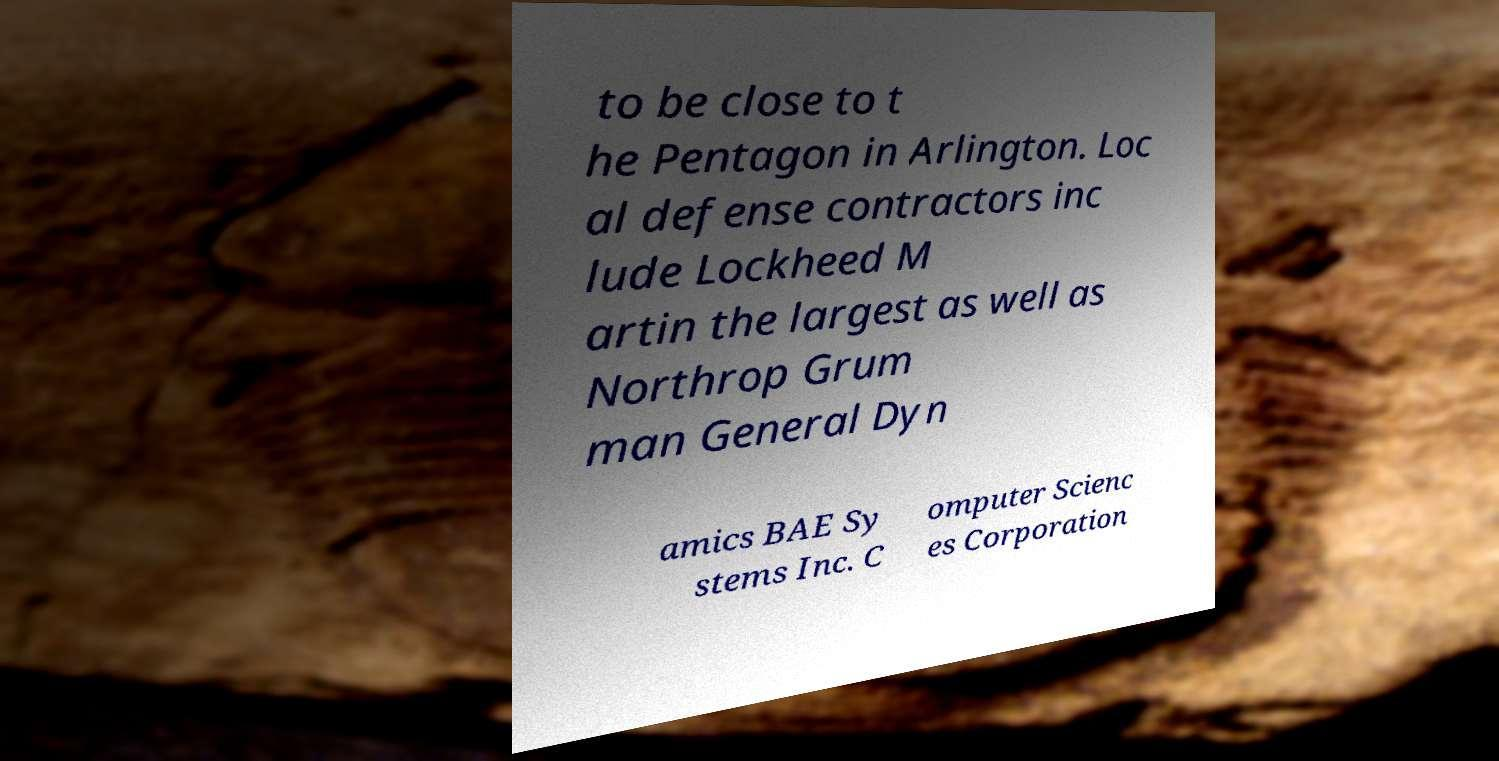I need the written content from this picture converted into text. Can you do that? to be close to t he Pentagon in Arlington. Loc al defense contractors inc lude Lockheed M artin the largest as well as Northrop Grum man General Dyn amics BAE Sy stems Inc. C omputer Scienc es Corporation 